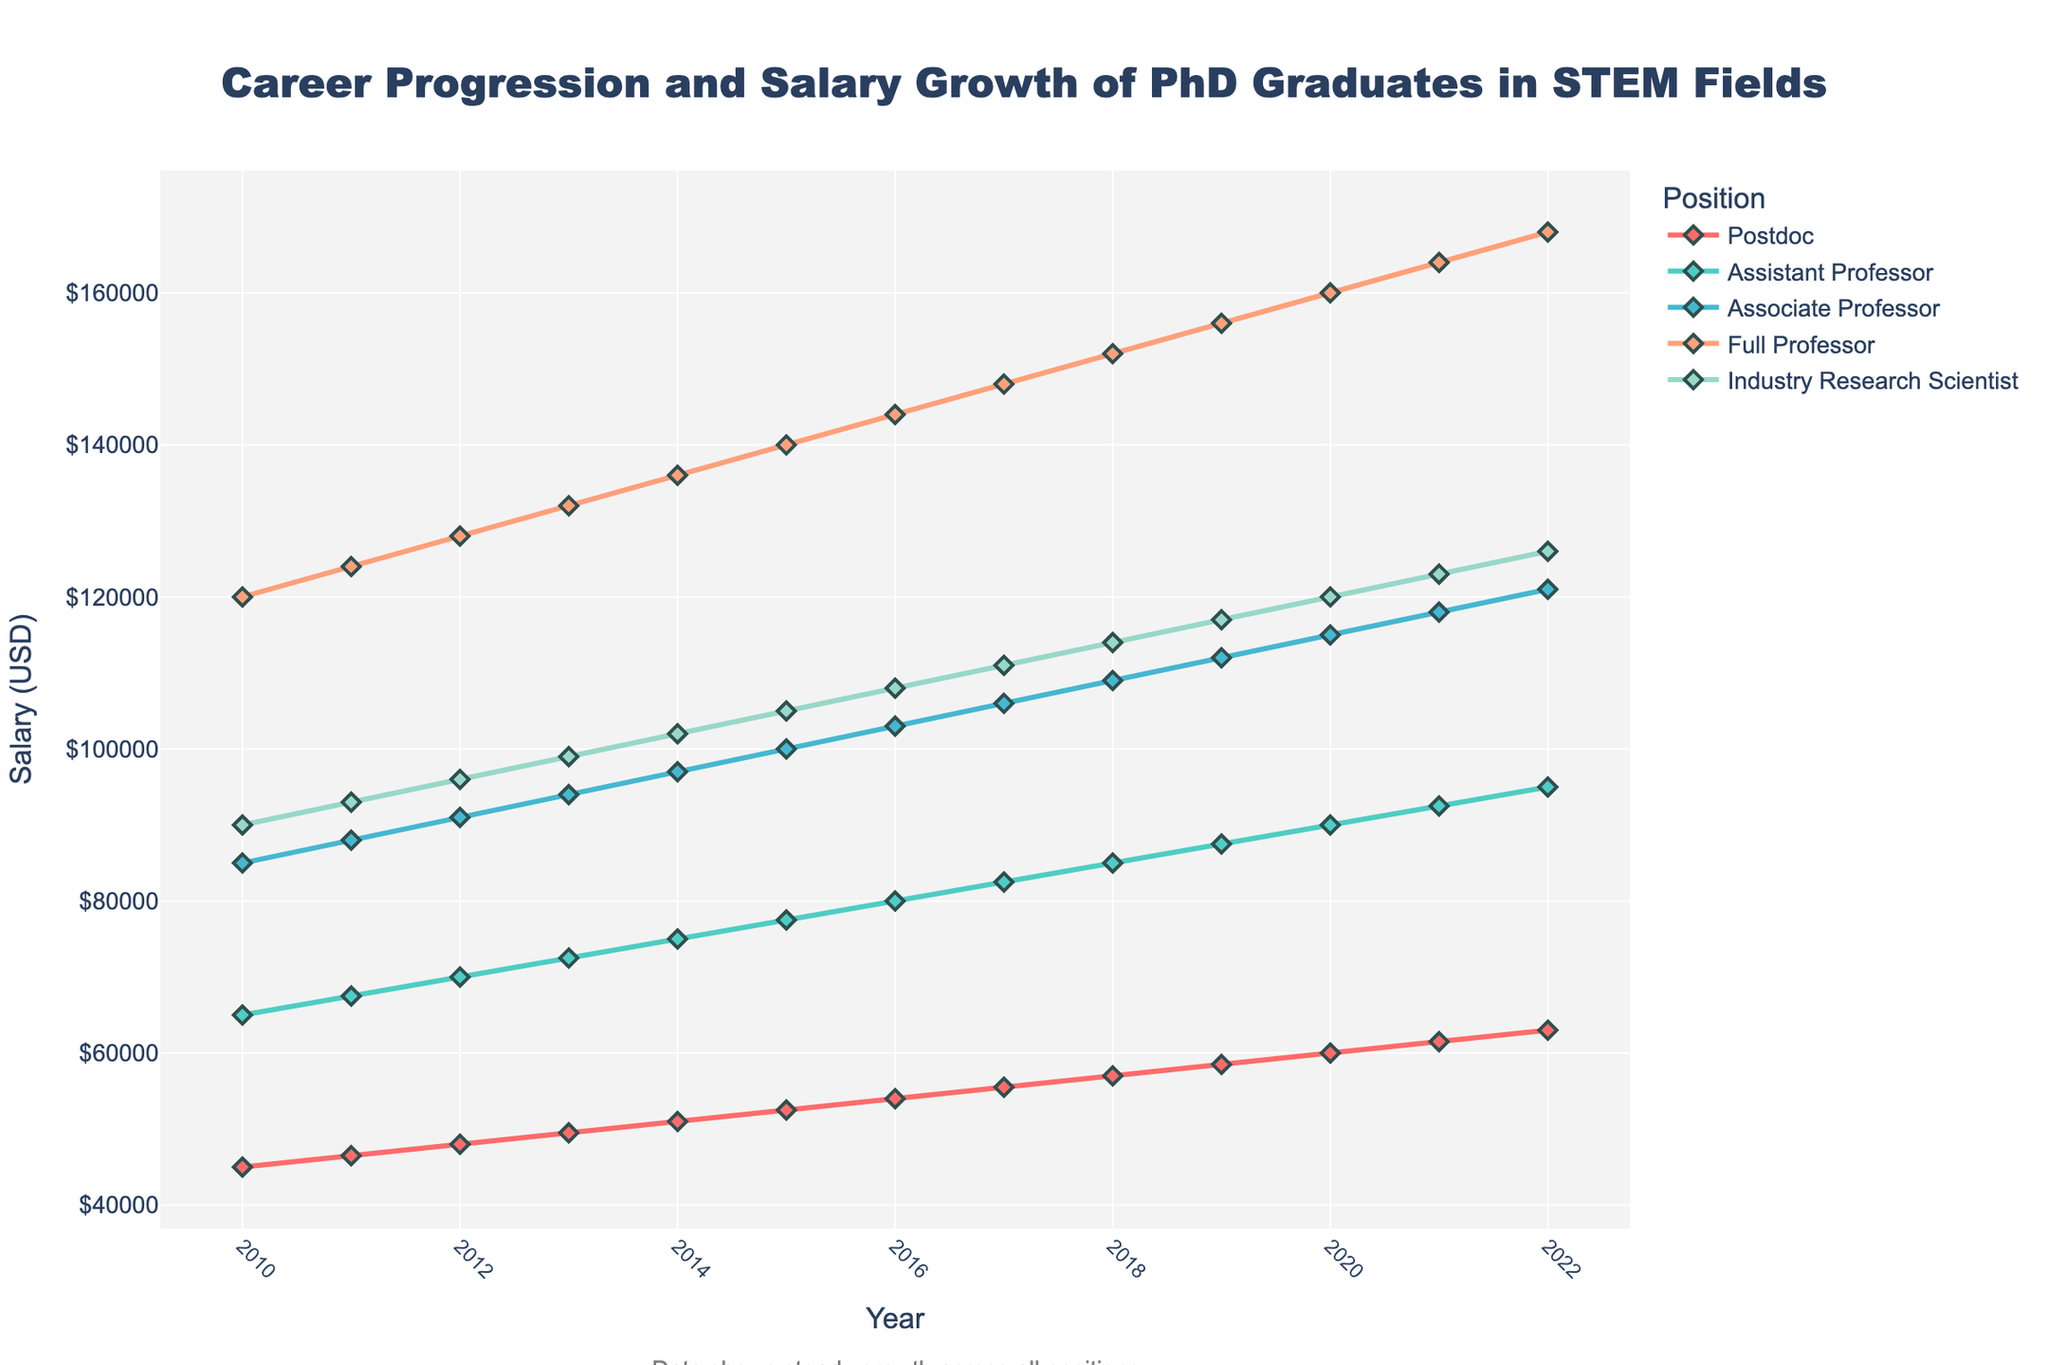What is the overall trend observed in the salaries of PhD graduates in STEM fields from 2010 to 2022? The line chart shows a steady upward trend in the salaries for all positions (Postdoc, Assistant Professor, Associate Professor, Full Professor, Industry Research Scientist) from 2010 to 2022, indicating consistent salary growth over this period.
Answer: Steady upward trend Which position had the highest salary in 2022? According to the line chart, the Full Professor position had the highest salary in 2022.
Answer: Full Professor How much did the salary of an Industry Research Scientist increase from 2010 to 2022? In 2010, the salary for an Industry Research Scientist was $90,000. In 2022, it was $126,000. The increase is $126,000 - $90,000 = $36,000.
Answer: $36,000 Which position shows the smallest gap in salary growth between 2015 and 2020? By comparing the salary values from 2015 to 2020 for each position, the Postdoc salary increased from $52,500 to $60,000, a $7,500 increase, which is the smallest gap among the positions shown in the chart.
Answer: Postdoc Compare the salary of an Assistant Professor to that of an Associate Professor in 2016. Which is higher, and by how much? In 2016, the salary of an Assistant Professor was $80,000 and that of an Associate Professor was $103,000. The difference is $103,000 - $80,000 = $23,000, with the Associate Professor salary being higher.
Answer: The Associate Professor salary is higher by $23,000 What is the average salary of a Full Professor from 2010 to 2022? The salaries of a Full Professor from 2010 to 2022 are: $120,000, $124,000, $128,000, $132,000, $136,000, $140,000, $144,000, $148,000, $152,000, $156,000, $160,000, $164,000, $168,000. Summing these values gives $1,732,000. Dividing by 13 (the number of years) gives $1,732,000 / 13 ≈ $133,230.77.
Answer: $133,230.77 By how much did the salary of an Associate Professor increase from 2011 to 2022? The salary of an Associate Professor increased from $88,000 in 2011 to $121,000 in 2022. The increase is $121,000 - $88,000 = $33,000.
Answer: $33,000 Which positions have salaries that intersect within the given period, and in what year does this occur? The chart shows that the salaries of an Industry Research Scientist and an Associate Professor intersect in 2012, where both are around $91,000.
Answer: Industry Research Scientist and Associate Professor in 2012 